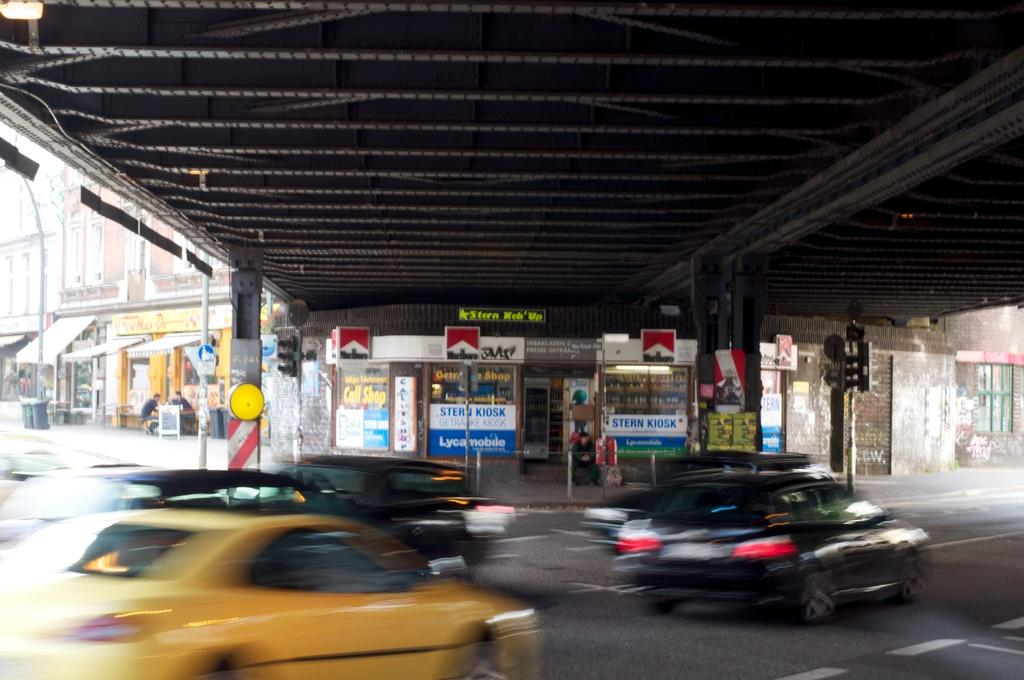<image>
Offer a succinct explanation of the picture presented. The Stern convenience store sells Marlboro brand cigarettes. 